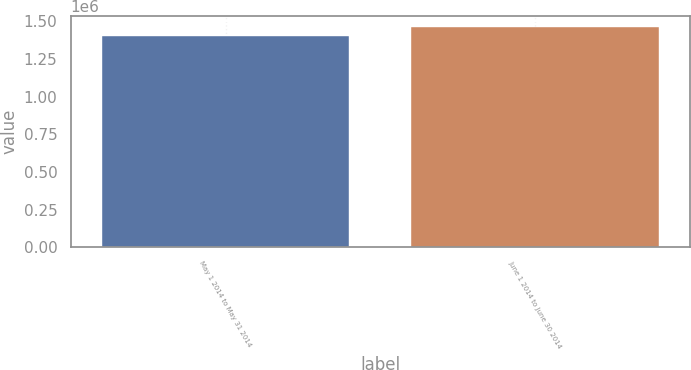Convert chart. <chart><loc_0><loc_0><loc_500><loc_500><bar_chart><fcel>May 1 2014 to May 31 2014<fcel>June 1 2014 to June 30 2014<nl><fcel>1.40289e+06<fcel>1.46257e+06<nl></chart> 